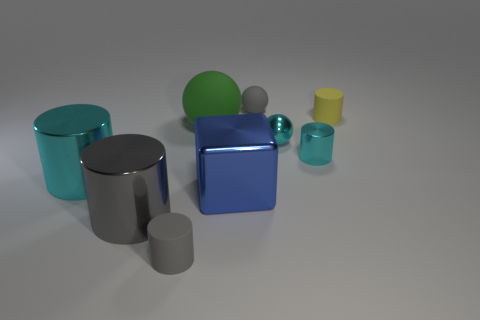What is the material of the small cylinder that is the same color as the tiny shiny sphere?
Give a very brief answer. Metal. There is a gray thing that is on the right side of the tiny gray rubber cylinder that is right of the big shiny cylinder behind the large blue block; what is its material?
Give a very brief answer. Rubber. Are there the same number of big gray metal objects that are in front of the big gray cylinder and red metal blocks?
Provide a short and direct response. Yes. How many things are either metallic things or large things?
Offer a terse response. 6. What is the shape of the blue object that is made of the same material as the large gray cylinder?
Make the answer very short. Cube. What is the size of the cyan shiny cylinder on the right side of the green ball that is to the left of the blue block?
Offer a very short reply. Small. How many tiny things are either blue rubber things or gray matte cylinders?
Offer a very short reply. 1. How many other things are the same color as the block?
Ensure brevity in your answer.  0. There is a cyan cylinder that is to the right of the blue metallic block; is its size the same as the rubber sphere that is behind the yellow matte object?
Offer a terse response. Yes. Does the big green sphere have the same material as the cyan cylinder that is on the right side of the big gray object?
Offer a terse response. No. 